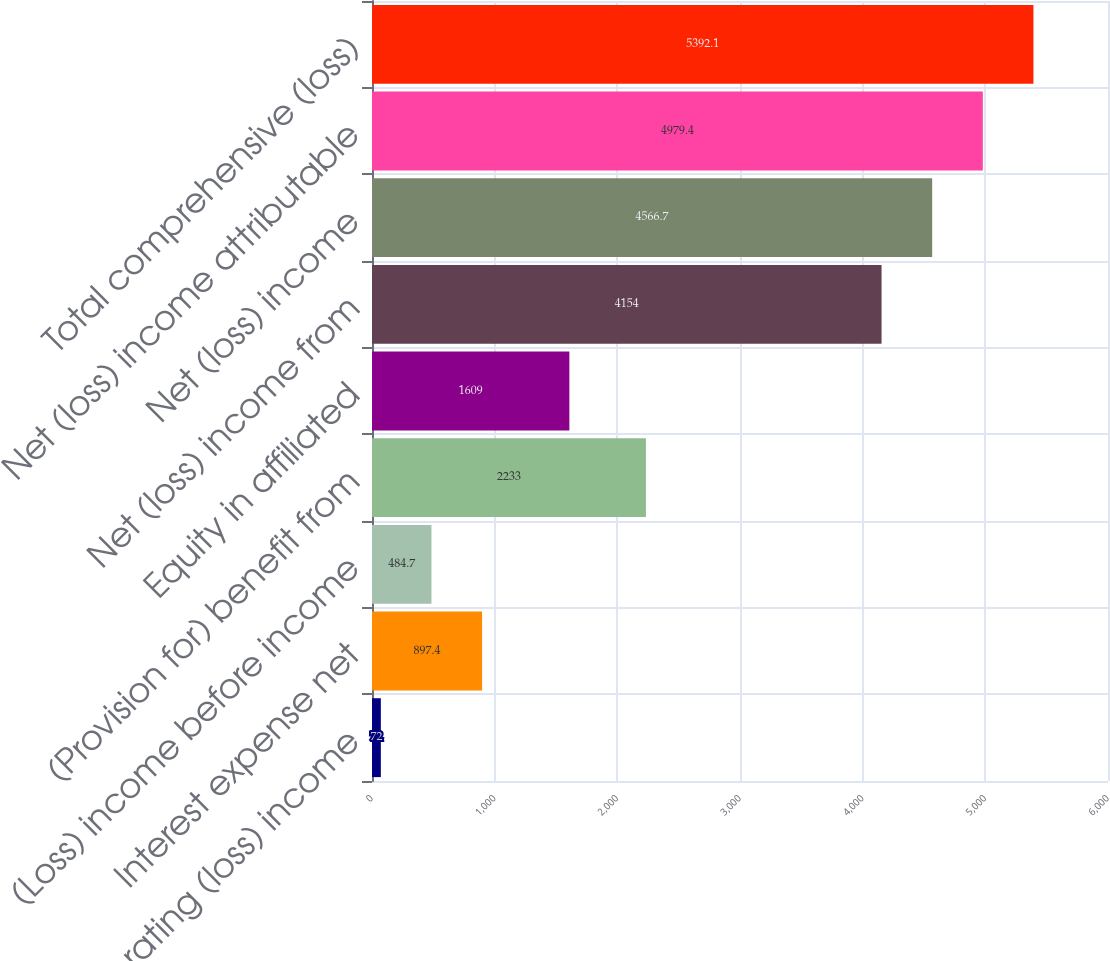Convert chart to OTSL. <chart><loc_0><loc_0><loc_500><loc_500><bar_chart><fcel>Operating (loss) income<fcel>Interest expense net<fcel>(Loss) income before income<fcel>(Provision for) benefit from<fcel>Equity in affiliated<fcel>Net (loss) income from<fcel>Net (loss) income<fcel>Net (loss) income attributable<fcel>Total comprehensive (loss)<nl><fcel>72<fcel>897.4<fcel>484.7<fcel>2233<fcel>1609<fcel>4154<fcel>4566.7<fcel>4979.4<fcel>5392.1<nl></chart> 